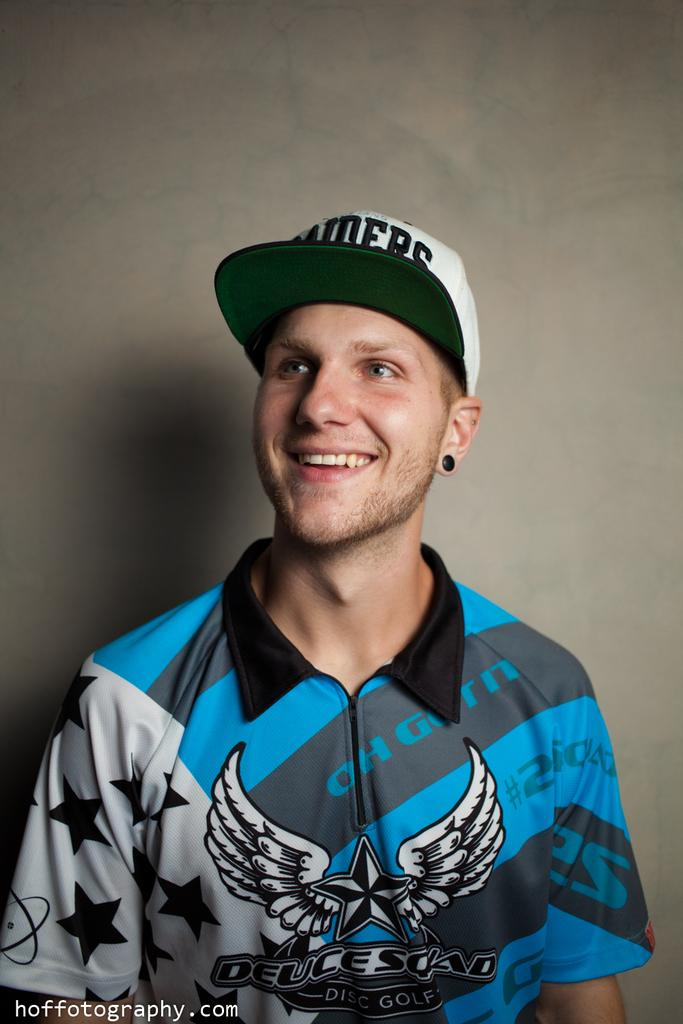<image>
Create a compact narrative representing the image presented. Young man with a zip up shirt that has deucesquad on the front in black lettering. 